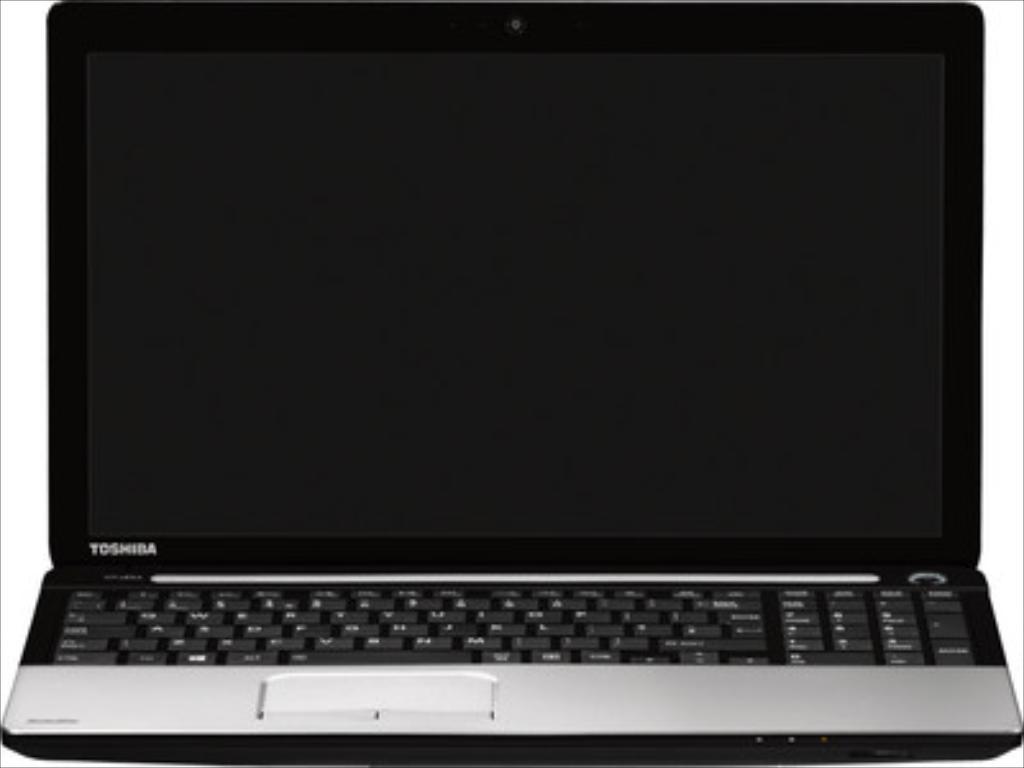What brand of laptop is this?
Offer a very short reply. Toshiba. 